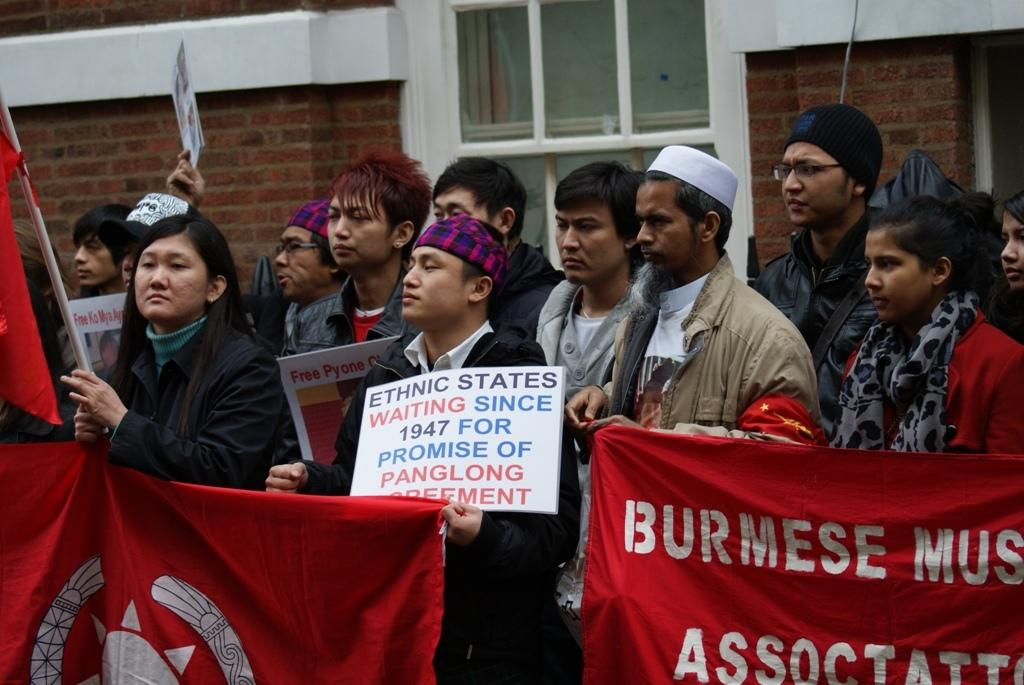What are the people in the image holding? The people in the image are holding posters and banners. What can be seen in the background of the image? There is a wall and a window in the background of the image. What type of scale is used to weigh the posters and banners in the image? There is no scale present in the image, and the posters and banners are not being weighed. 